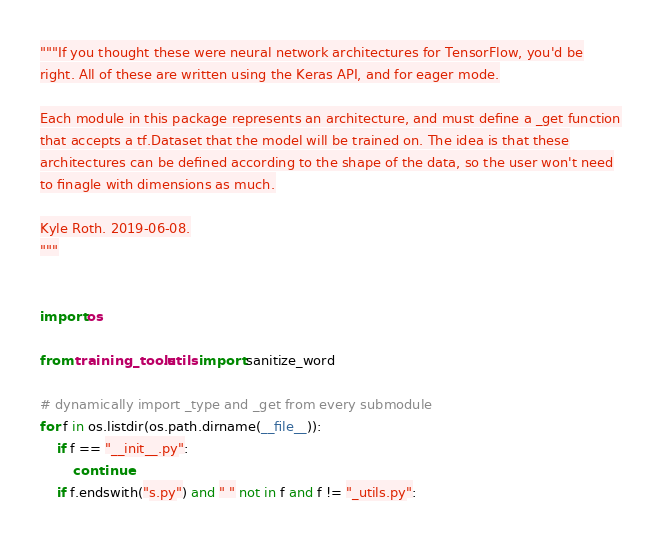Convert code to text. <code><loc_0><loc_0><loc_500><loc_500><_Python_>"""If you thought these were neural network architectures for TensorFlow, you'd be
right. All of these are written using the Keras API, and for eager mode.

Each module in this package represents an architecture, and must define a _get function
that accepts a tf.Dataset that the model will be trained on. The idea is that these
architectures can be defined according to the shape of the data, so the user won't need
to finagle with dimensions as much.

Kyle Roth. 2019-06-08.
"""


import os

from training_tools.utils import sanitize_word

# dynamically import _type and _get from every submodule
for f in os.listdir(os.path.dirname(__file__)):
    if f == "__init__.py":
        continue
    if f.endswith("s.py") and " " not in f and f != "_utils.py":</code> 